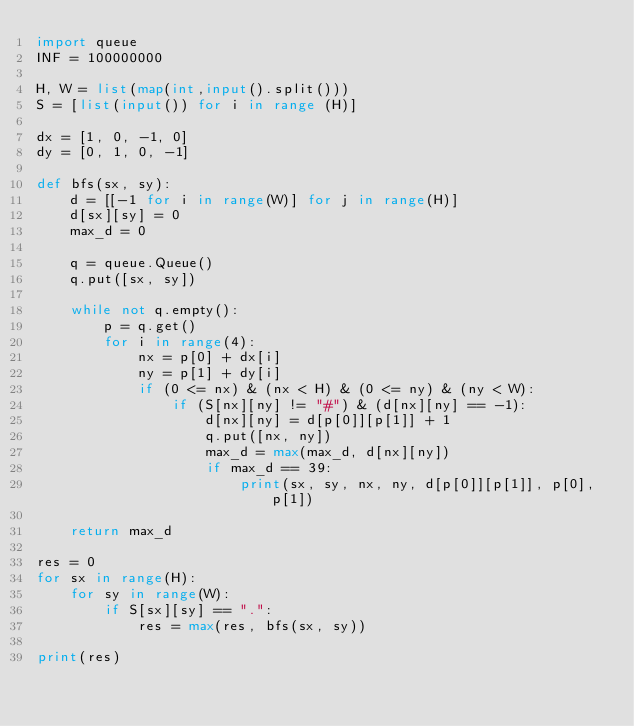<code> <loc_0><loc_0><loc_500><loc_500><_Python_>import queue
INF = 100000000

H, W = list(map(int,input().split()))
S = [list(input()) for i in range (H)]

dx = [1, 0, -1, 0]
dy = [0, 1, 0, -1]

def bfs(sx, sy):
    d = [[-1 for i in range(W)] for j in range(H)]
    d[sx][sy] = 0
    max_d = 0

    q = queue.Queue()
    q.put([sx, sy])

    while not q.empty():
        p = q.get()
        for i in range(4):
            nx = p[0] + dx[i]
            ny = p[1] + dy[i]
            if (0 <= nx) & (nx < H) & (0 <= ny) & (ny < W):
                if (S[nx][ny] != "#") & (d[nx][ny] == -1):
                    d[nx][ny] = d[p[0]][p[1]] + 1
                    q.put([nx, ny])
                    max_d = max(max_d, d[nx][ny])
                    if max_d == 39:
                        print(sx, sy, nx, ny, d[p[0]][p[1]], p[0], p[1])

    return max_d

res = 0
for sx in range(H):
    for sy in range(W):
        if S[sx][sy] == ".":
            res = max(res, bfs(sx, sy))

print(res)
</code> 